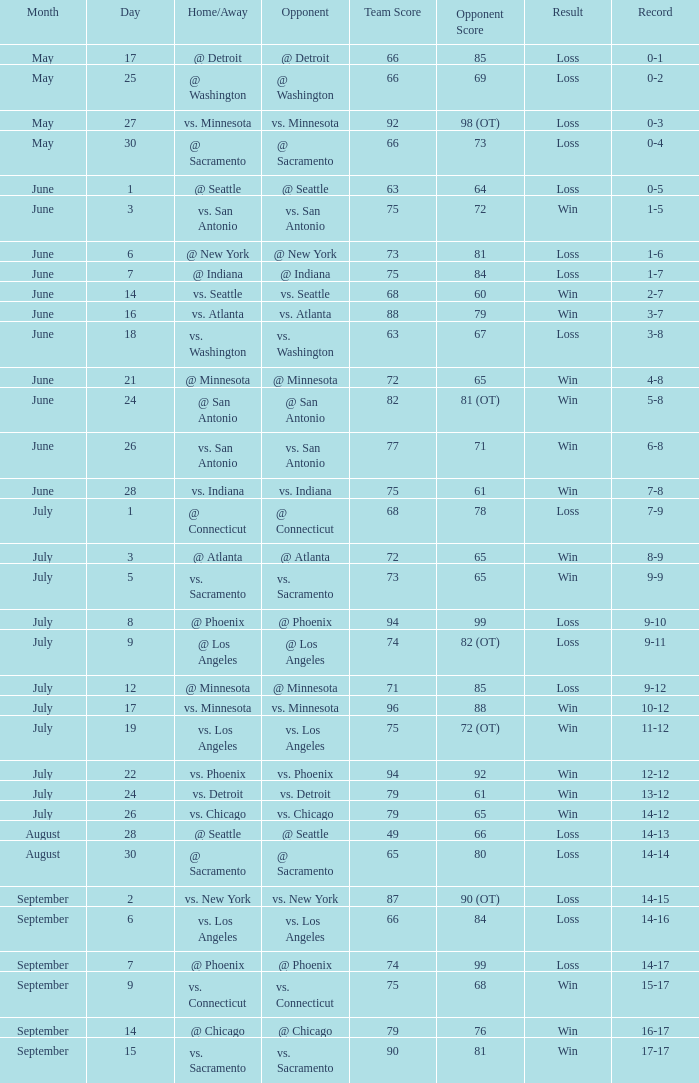What was the Score of the game with a Record of 0-1? 66-85. 